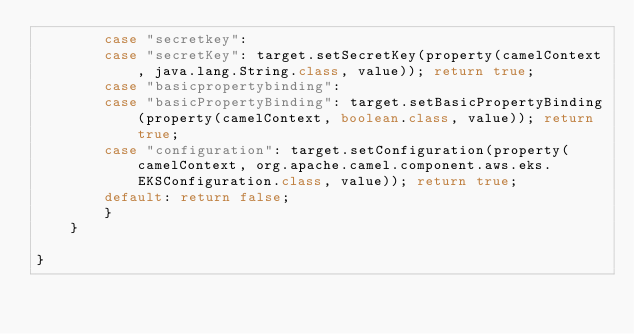<code> <loc_0><loc_0><loc_500><loc_500><_Java_>        case "secretkey":
        case "secretKey": target.setSecretKey(property(camelContext, java.lang.String.class, value)); return true;
        case "basicpropertybinding":
        case "basicPropertyBinding": target.setBasicPropertyBinding(property(camelContext, boolean.class, value)); return true;
        case "configuration": target.setConfiguration(property(camelContext, org.apache.camel.component.aws.eks.EKSConfiguration.class, value)); return true;
        default: return false;
        }
    }

}

</code> 